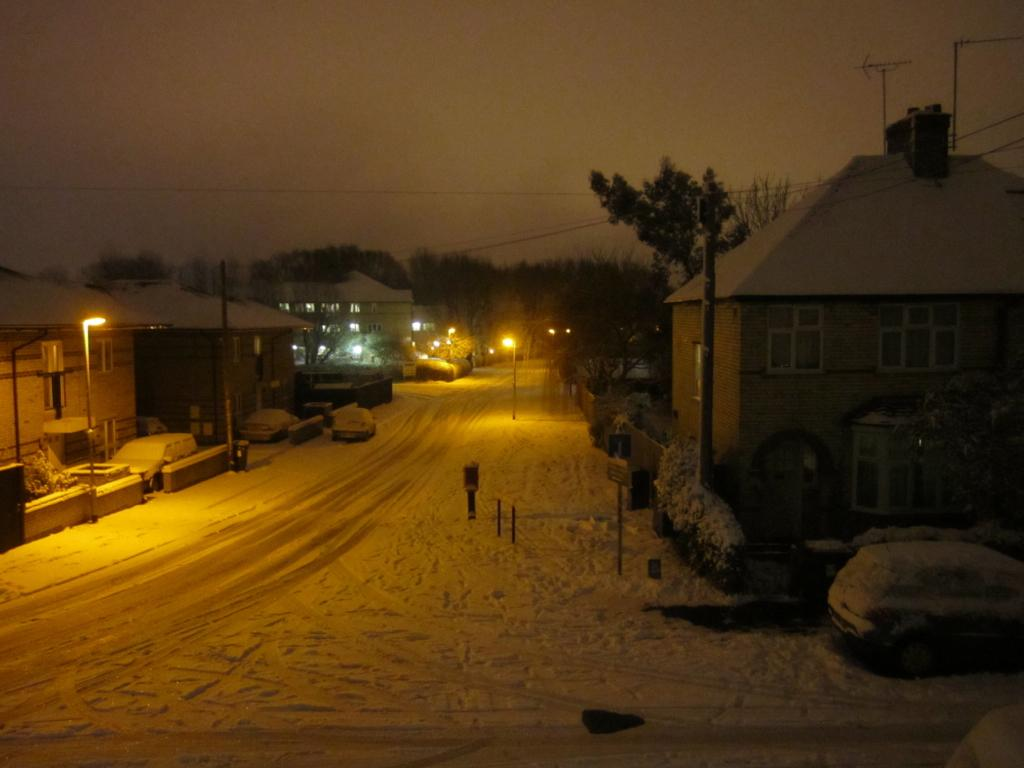What is the main feature of the image? There is a road in the image. What is the condition of the road? There is snow on the road. What can be seen along the road? There are poles, lights, a car, buildings, and trees on both sides of the road. What is visible in the background of the image? The sky is visible in the background of the image. Where is the stove located in the image? There is no stove present in the image. What type of print can be seen on the car in the image? There is no print visible on the car in the image. 